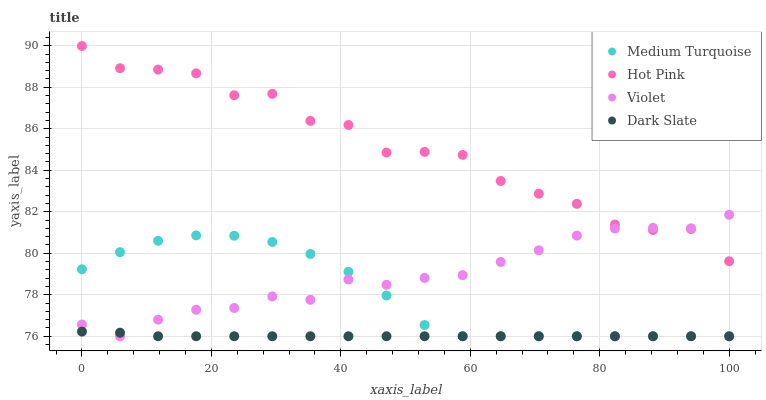Does Dark Slate have the minimum area under the curve?
Answer yes or no. Yes. Does Hot Pink have the maximum area under the curve?
Answer yes or no. Yes. Does Medium Turquoise have the minimum area under the curve?
Answer yes or no. No. Does Medium Turquoise have the maximum area under the curve?
Answer yes or no. No. Is Dark Slate the smoothest?
Answer yes or no. Yes. Is Hot Pink the roughest?
Answer yes or no. Yes. Is Medium Turquoise the smoothest?
Answer yes or no. No. Is Medium Turquoise the roughest?
Answer yes or no. No. Does Dark Slate have the lowest value?
Answer yes or no. Yes. Does Hot Pink have the lowest value?
Answer yes or no. No. Does Hot Pink have the highest value?
Answer yes or no. Yes. Does Medium Turquoise have the highest value?
Answer yes or no. No. Is Medium Turquoise less than Hot Pink?
Answer yes or no. Yes. Is Hot Pink greater than Medium Turquoise?
Answer yes or no. Yes. Does Violet intersect Hot Pink?
Answer yes or no. Yes. Is Violet less than Hot Pink?
Answer yes or no. No. Is Violet greater than Hot Pink?
Answer yes or no. No. Does Medium Turquoise intersect Hot Pink?
Answer yes or no. No. 